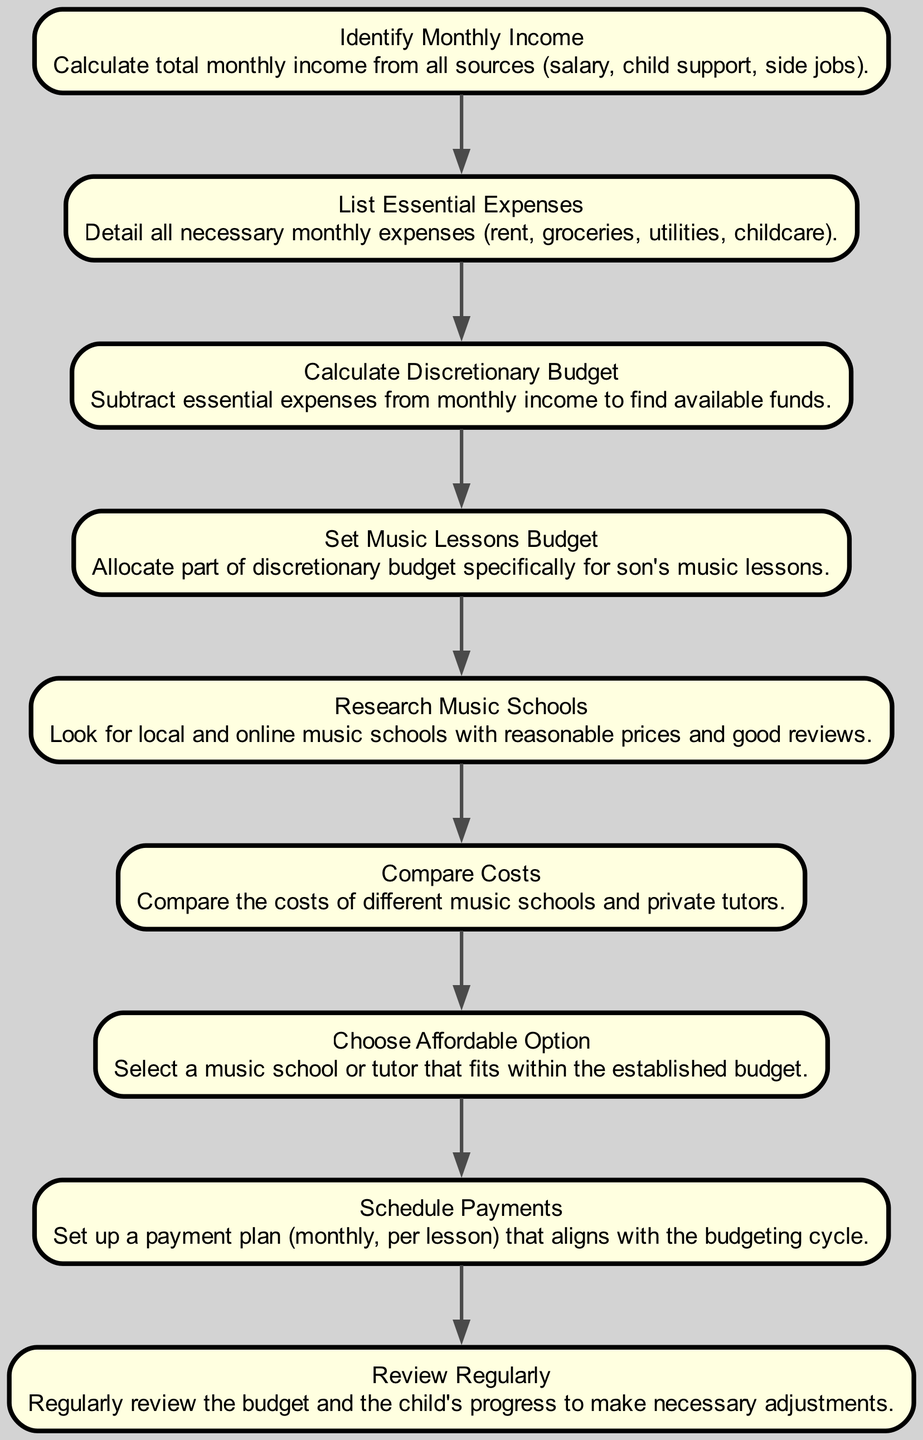What is the first step in the budget management process? The first step is "Identify Monthly Income". This is indicated as the starting point of the flowchart, from which all other steps logically follow.
Answer: Identify Monthly Income How many total steps are there in the budget management diagram? The diagram contains nine distinct nodes, each representing a step in the process, culminating in the last step "Review Regularly".
Answer: Nine What comes after "Set Music Lessons Budget"? The process continues with "Research Music Schools". This is shown by the directed edge leading from "Set Music Lessons Budget" to the next node in the sequence.
Answer: Research Music Schools What is the final step of the budget management process? The last node is "Review Regularly", indicating it is the concluding activity in the outlined budget management flow.
Answer: Review Regularly Which step involves allocating funds specifically for music lessons? The step that directly relates to allocating funds is "Set Music Lessons Budget", where a portion of the discretionary budget is designated for music lessons.
Answer: Set Music Lessons Budget If essential expenses exceed monthly income, what action would be implied? If essential expenses surpass monthly income, it implies that the "Calculate Discretionary Budget" would result in a negative value or no available funds, making it necessary to revisit earlier steps.
Answer: N/A How is the relationship between "Research Music Schools" and "Compare Costs"? "Research Music Schools" leads directly into "Compare Costs", meaning you first identify schools before evaluating their costs, as shown by the directional flow in the diagram.
Answer: Direct relationship Which step requires examining music schools' prices? The step called "Compare Costs" explicitly requires looking at the costs of different music schools and private tutors, as indicated in the flowchart.
Answer: Compare Costs 